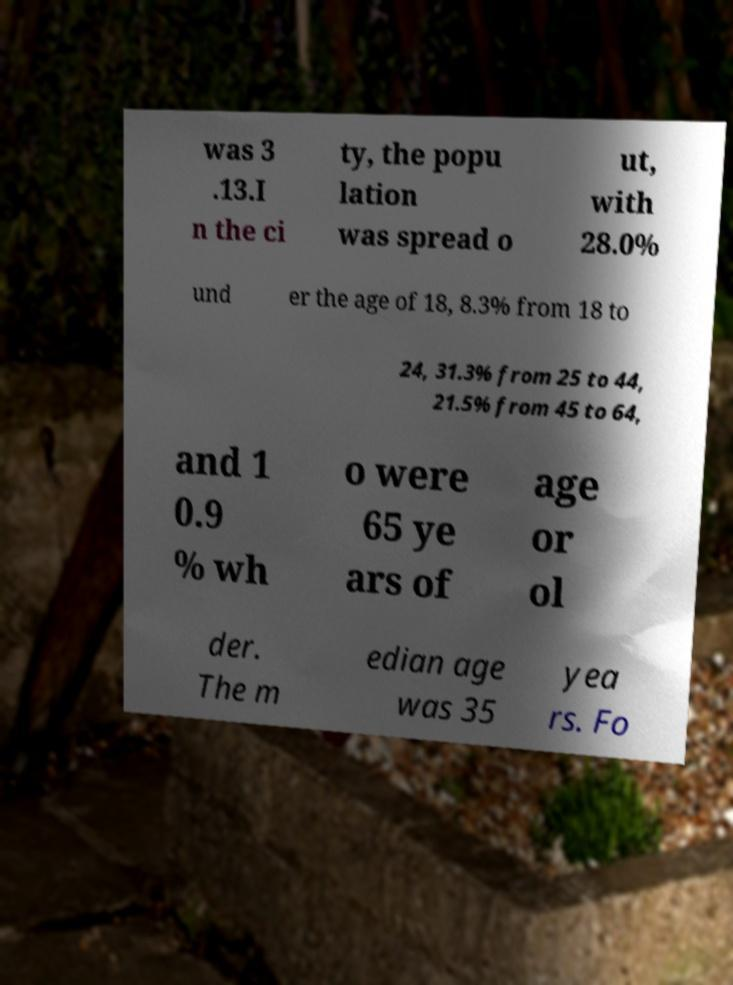Can you accurately transcribe the text from the provided image for me? was 3 .13.I n the ci ty, the popu lation was spread o ut, with 28.0% und er the age of 18, 8.3% from 18 to 24, 31.3% from 25 to 44, 21.5% from 45 to 64, and 1 0.9 % wh o were 65 ye ars of age or ol der. The m edian age was 35 yea rs. Fo 